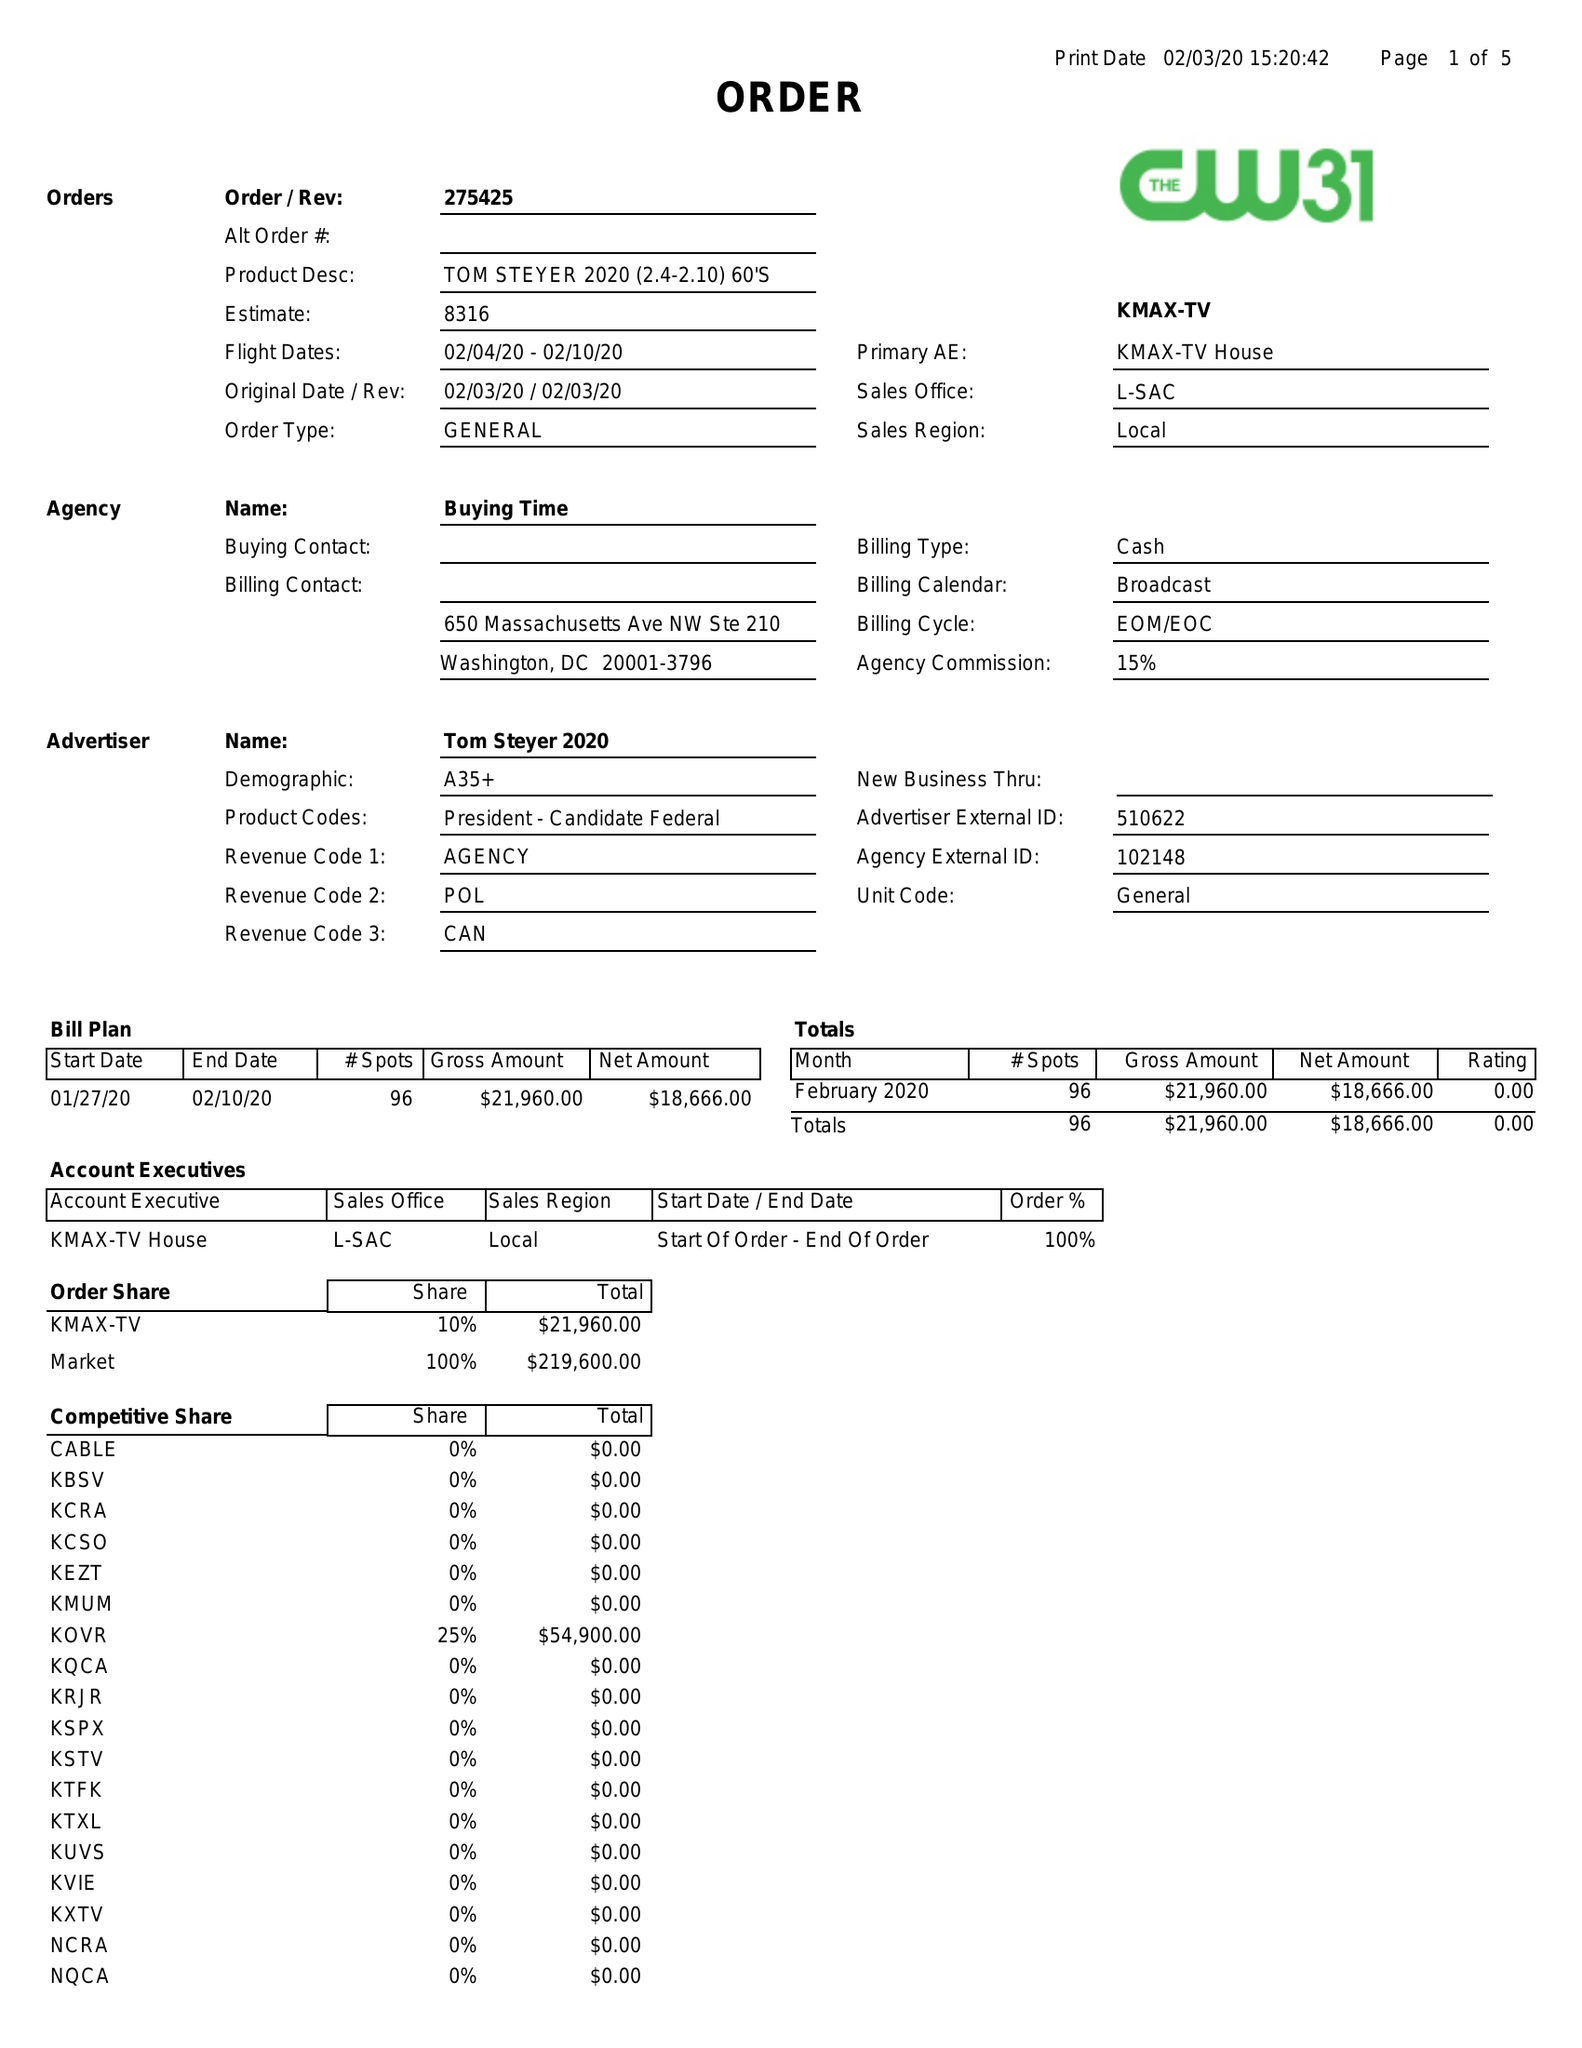What is the value for the gross_amount?
Answer the question using a single word or phrase. 21960.00 